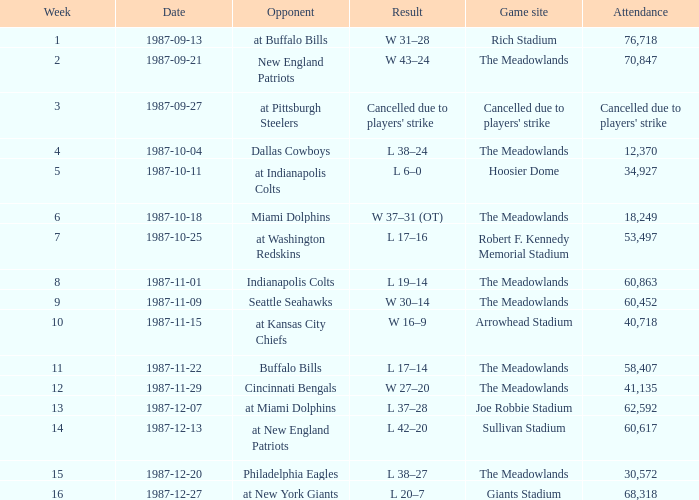Which team did the jets face in their pre-week 9 contest at the robert f. kennedy memorial stadium? At washington redskins. 